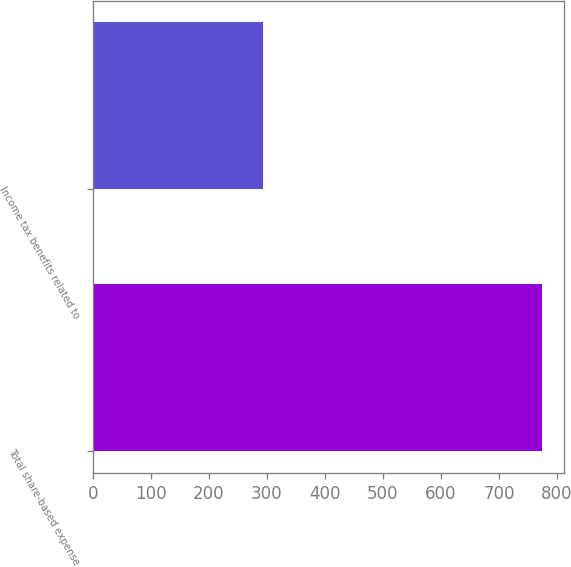<chart> <loc_0><loc_0><loc_500><loc_500><bar_chart><fcel>Total share-based expense<fcel>Income tax benefits related to<nl><fcel>774<fcel>294<nl></chart> 